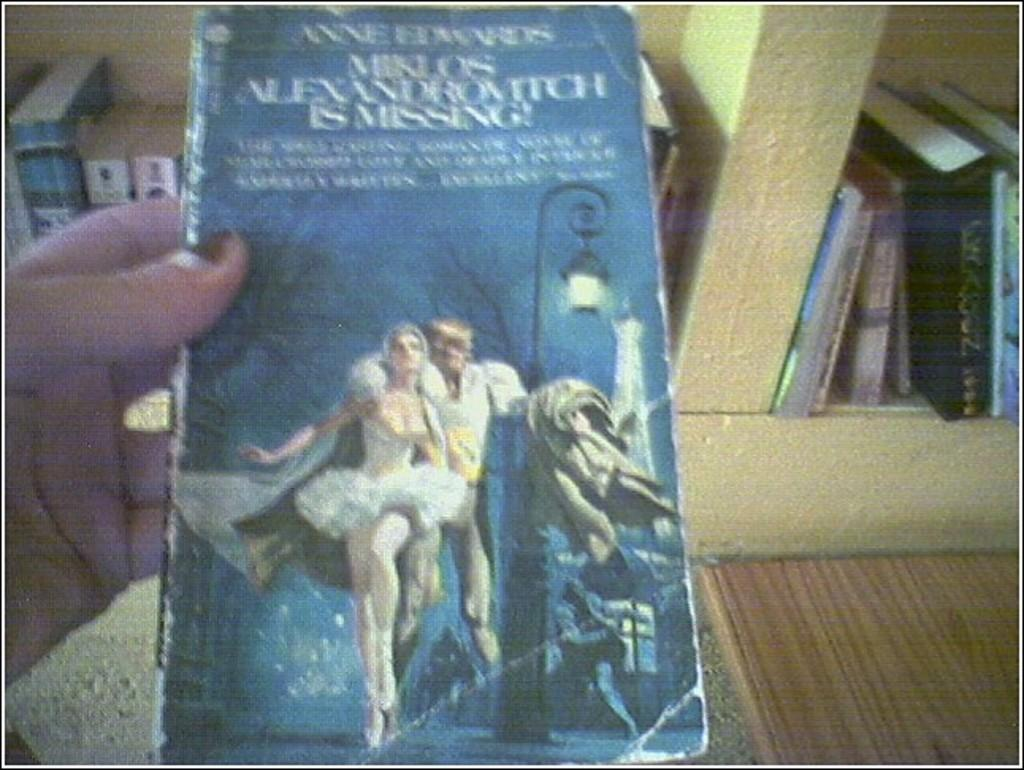What is the main subject in the foreground of the picture? There is a person in the foreground of the picture. What is the person holding in the image? The person is holding a book. What can be seen in the background of the picture? There are books in the background of the picture, and they are on a bookshelf. What type of furniture is visible on the right side of the image? There is a wooden desk on the right side of the image. Can you tell me how many giraffes are standing near the wooden desk in the image? There are no giraffes present in the image; it features a person holding a book, books on a bookshelf, and a wooden desk. What type of farming equipment is visible in the image? There is no farming equipment present in the image. 